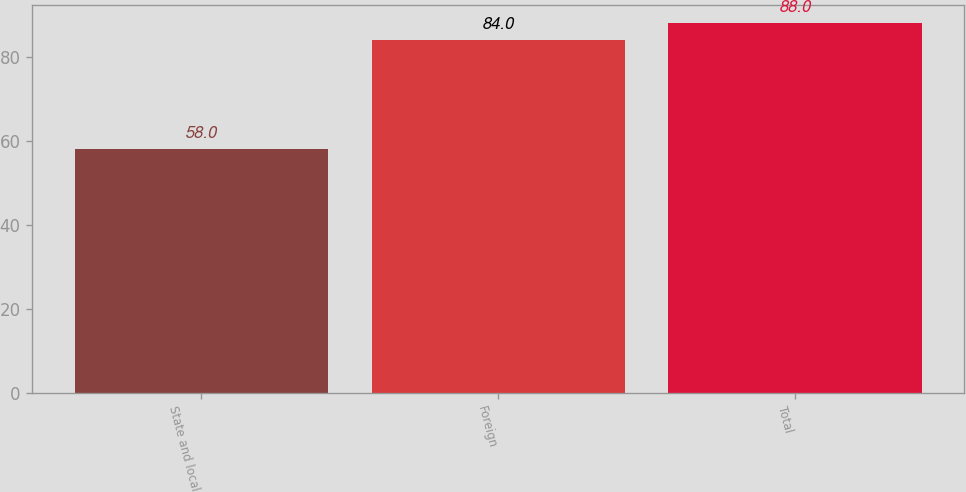<chart> <loc_0><loc_0><loc_500><loc_500><bar_chart><fcel>State and local<fcel>Foreign<fcel>Total<nl><fcel>58<fcel>84<fcel>88<nl></chart> 